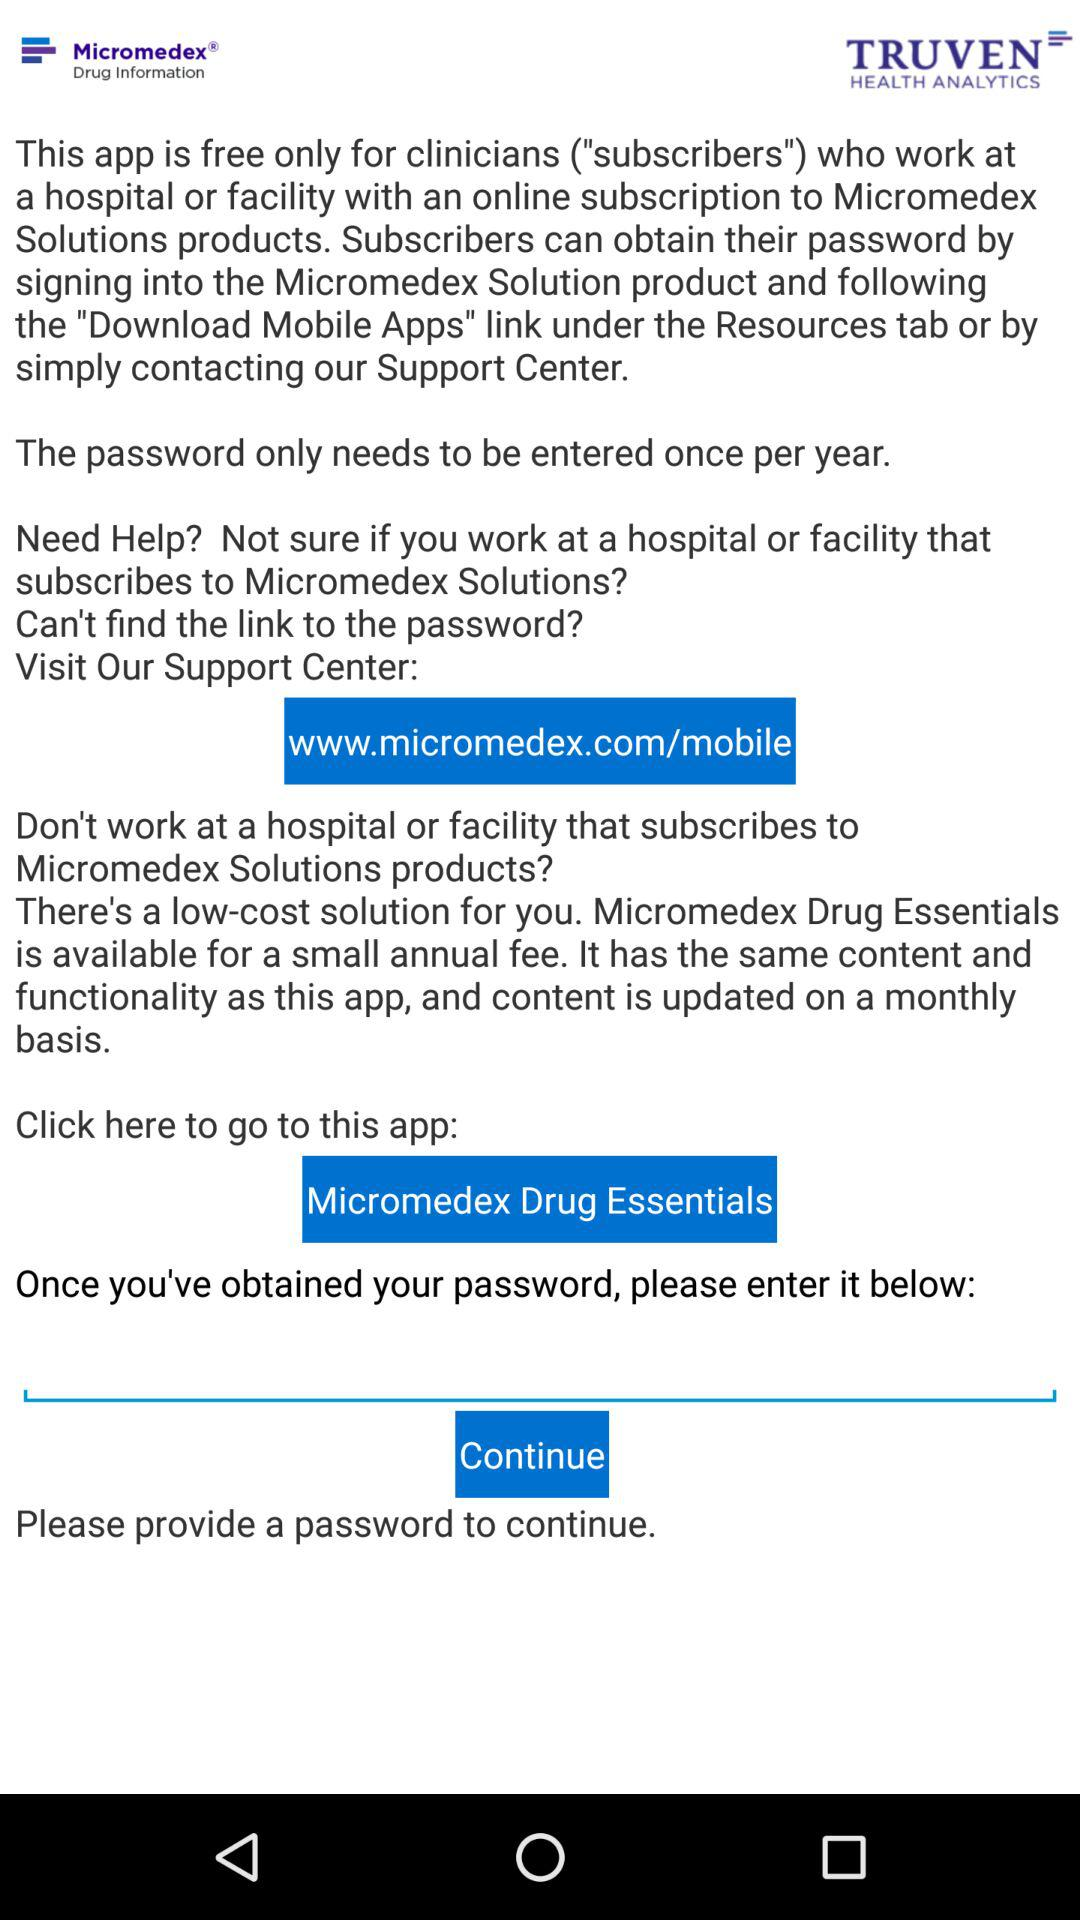What is the web address? The web address is www.micromedex.com/mobile. 